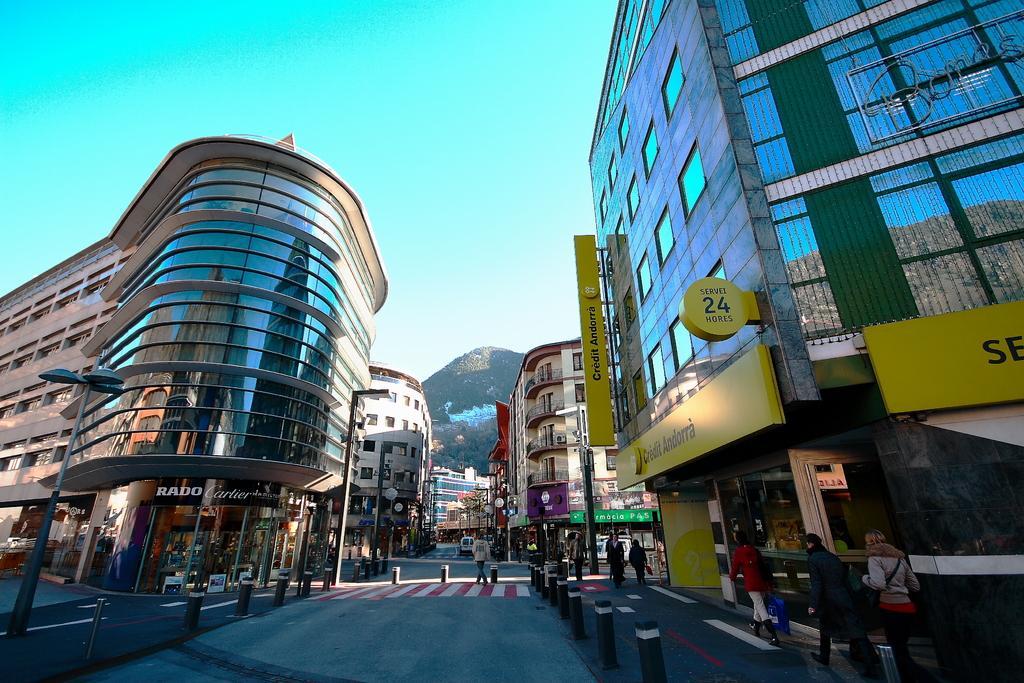Describe this image in one or two sentences. Buildings with glass windows. On these buildings there are hoardings. In-front of these buildings there are people.  